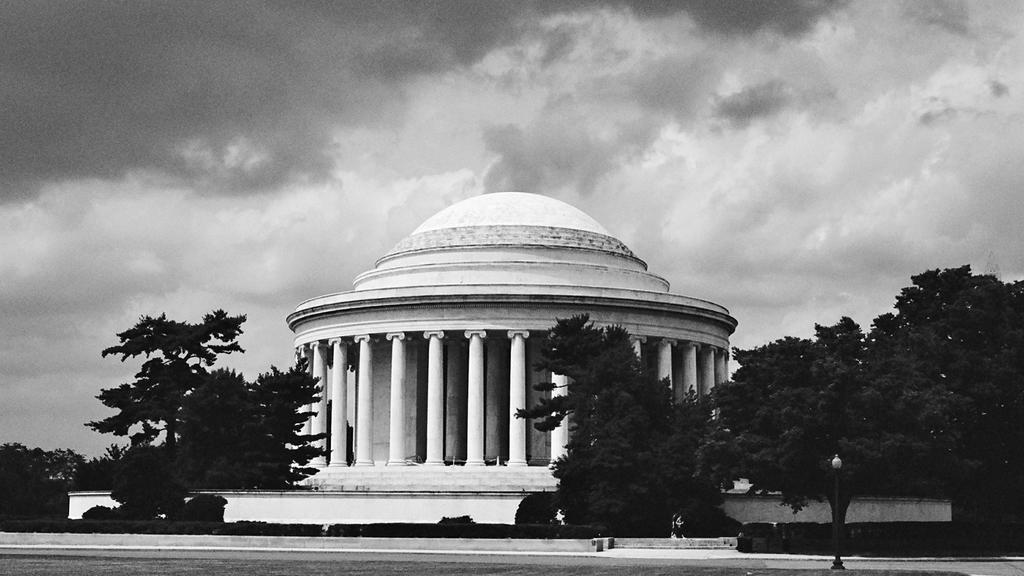What is the main feature of the image? There is a road in the image. What other elements can be seen in the image? There are trees, pillars, a building, and the sky visible in the background. What is the condition of the sky in the image? The sky is visible in the background, and clouds are present. What type of juice is being served in the building in the image? There is no juice or indication of any beverage being served in the image. The image only shows a road, trees, pillars, a building, and the sky with clouds. 